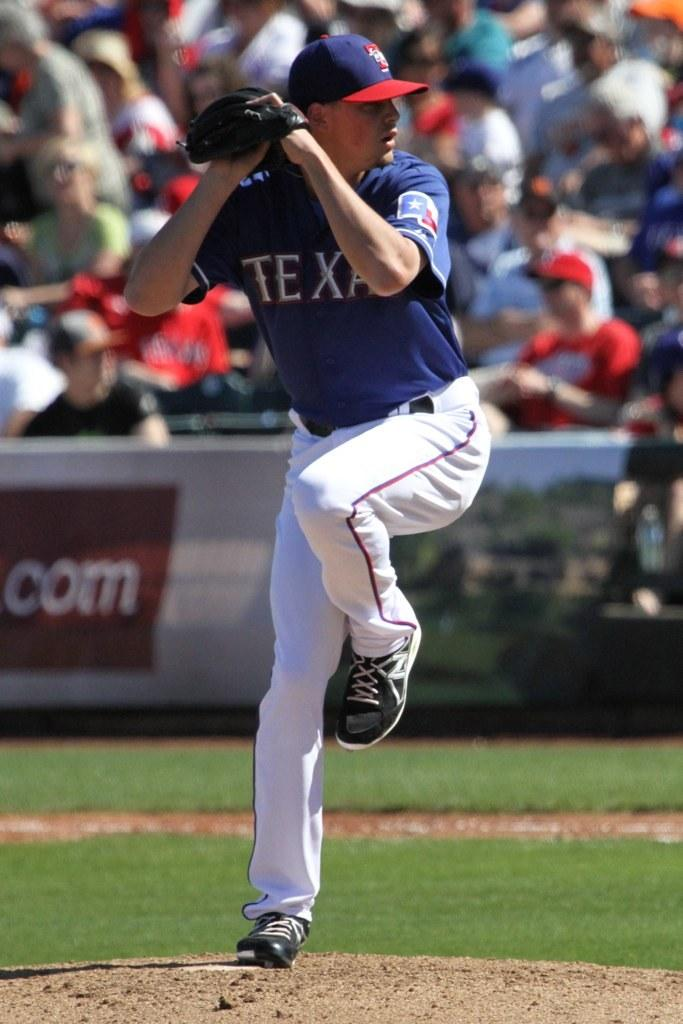<image>
Write a terse but informative summary of the picture. Baseball player for Texas is getting ready to pitch the ball. 